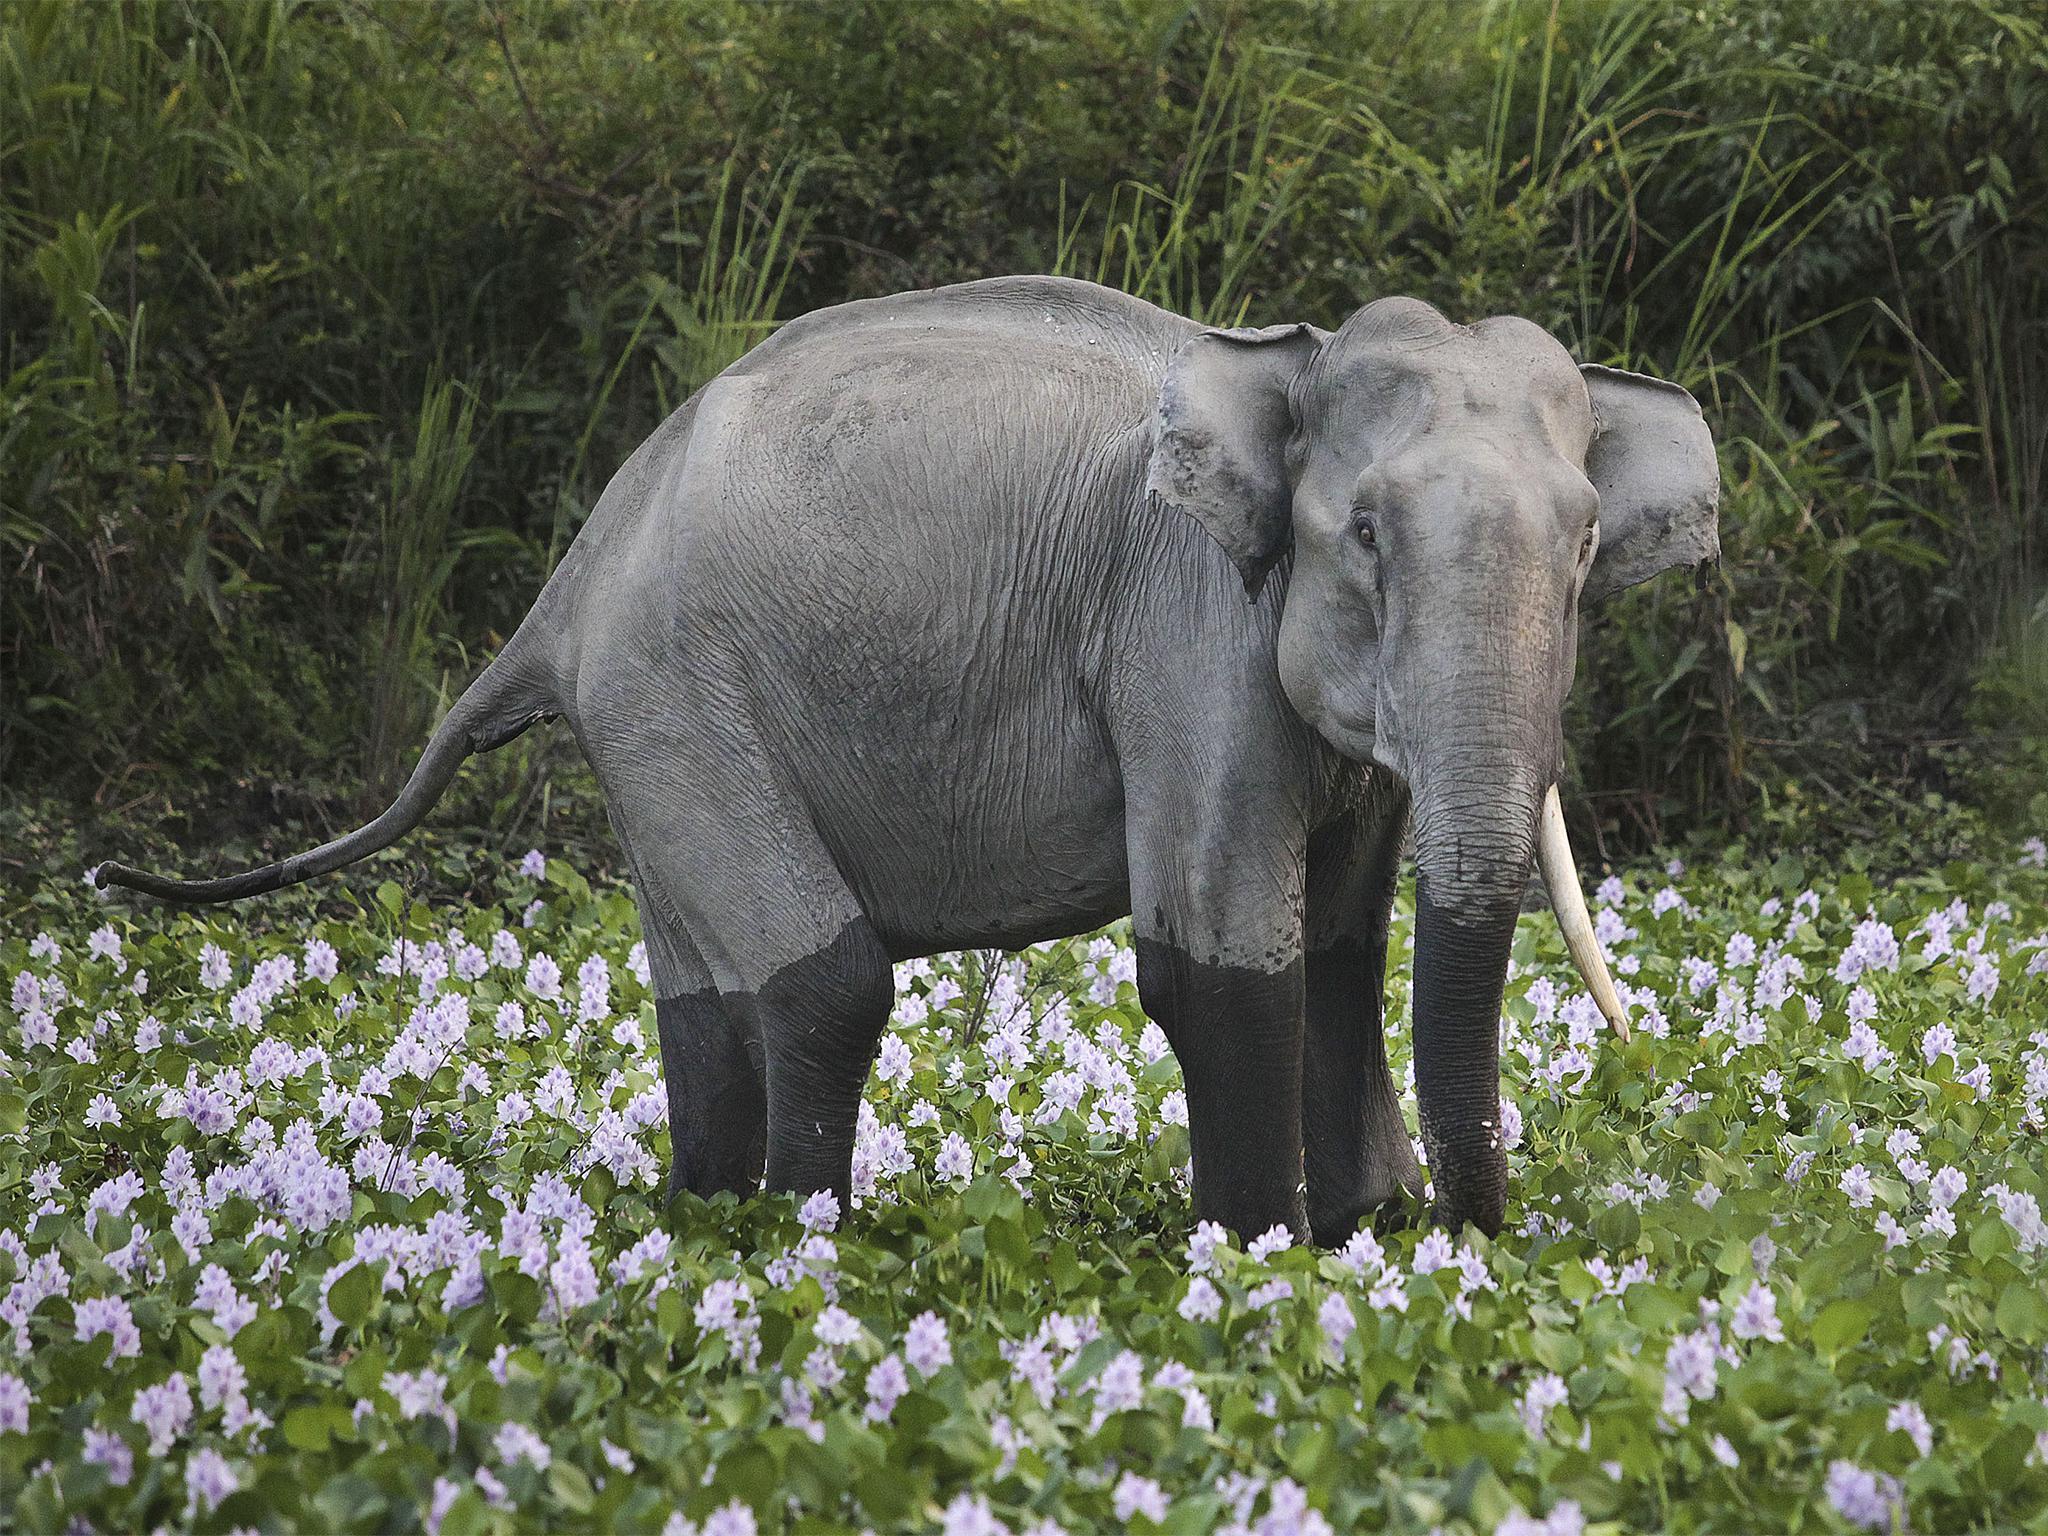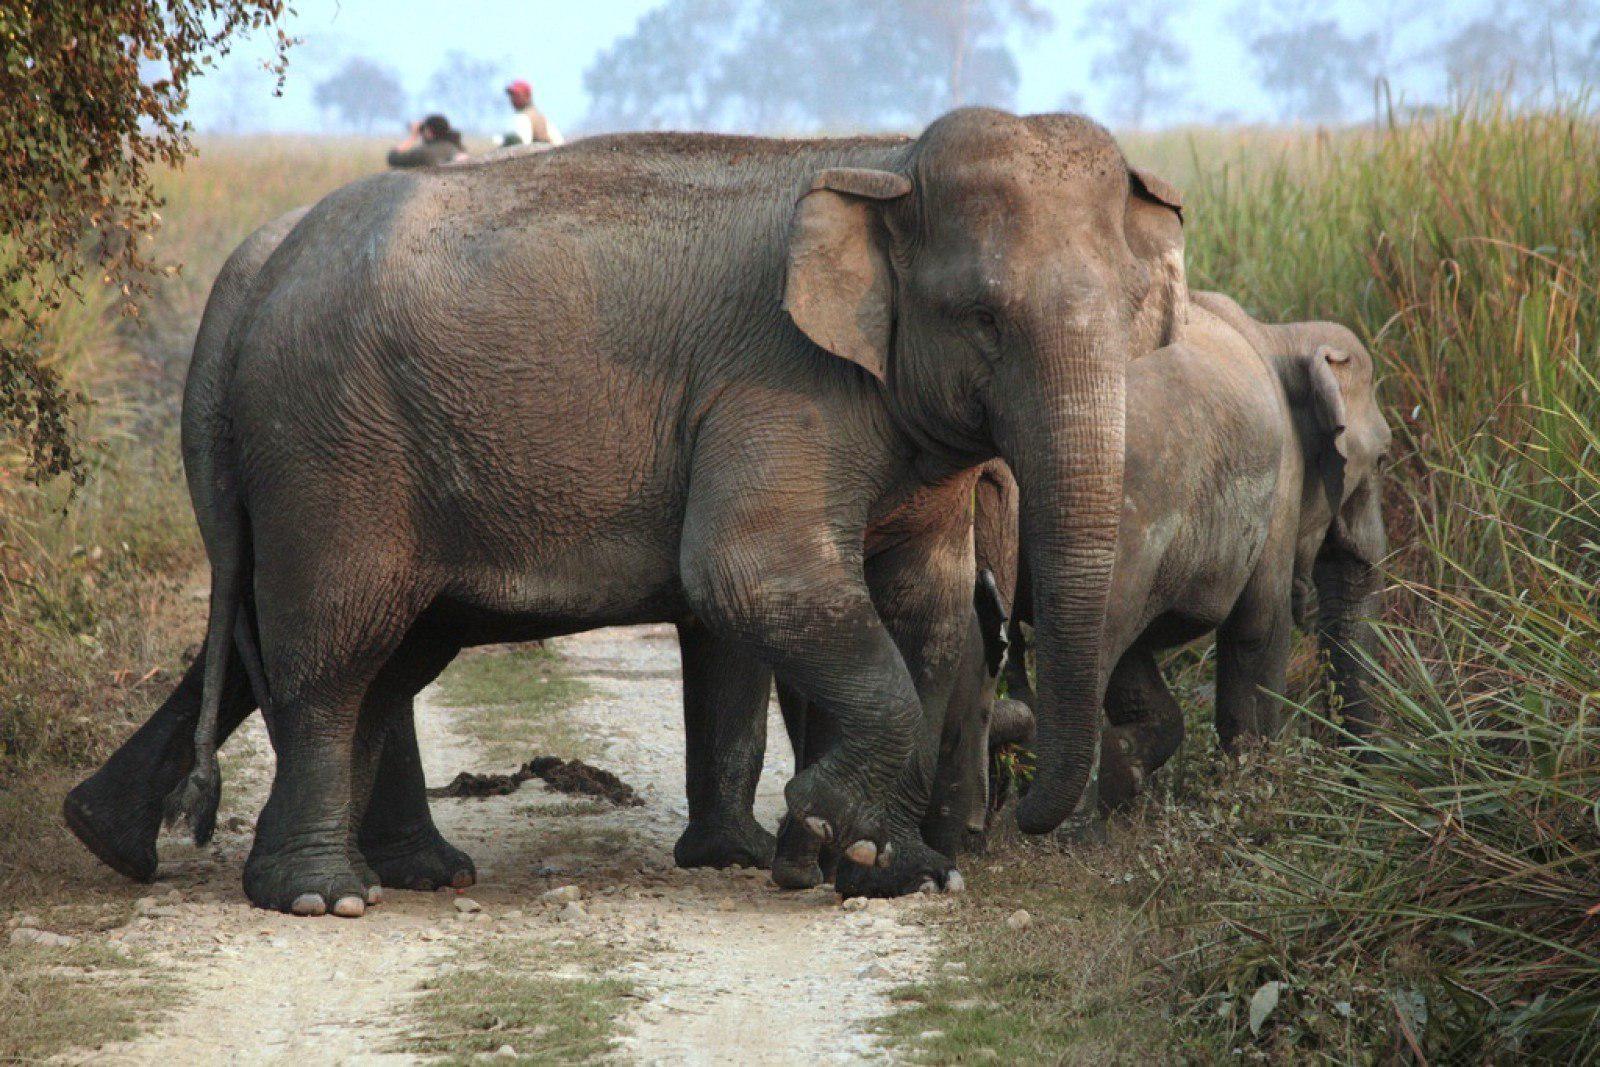The first image is the image on the left, the second image is the image on the right. For the images displayed, is the sentence "An image shows one baby elephant standing by one adult elephant on dry land." factually correct? Answer yes or no. No. 